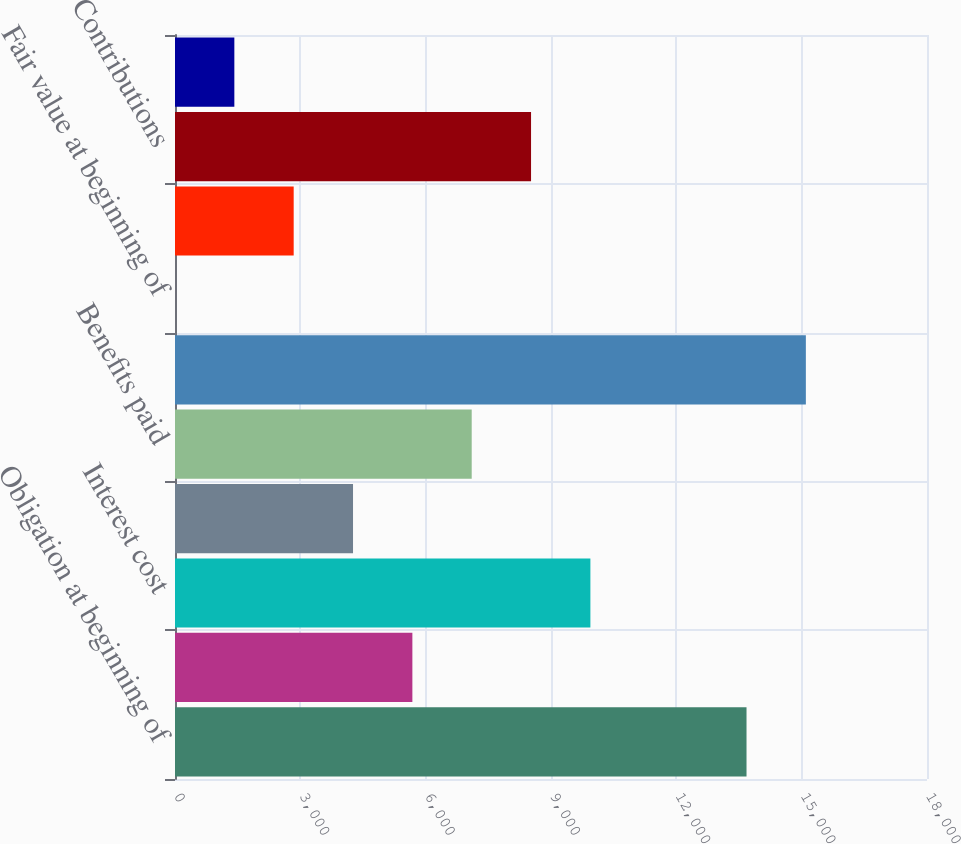Convert chart. <chart><loc_0><loc_0><loc_500><loc_500><bar_chart><fcel>Obligation at beginning of<fcel>Service cost<fcel>Interest cost<fcel>Actuarial loss (gain)<fcel>Benefits paid<fcel>Obligation at end of year<fcel>Fair value at beginning of<fcel>Return on assets<fcel>Contributions<fcel>Fair value at end of year<nl><fcel>13680<fcel>5681.67<fcel>9942.84<fcel>4261.28<fcel>7102.06<fcel>15100.4<fcel>0.11<fcel>2840.89<fcel>8522.45<fcel>1420.5<nl></chart> 